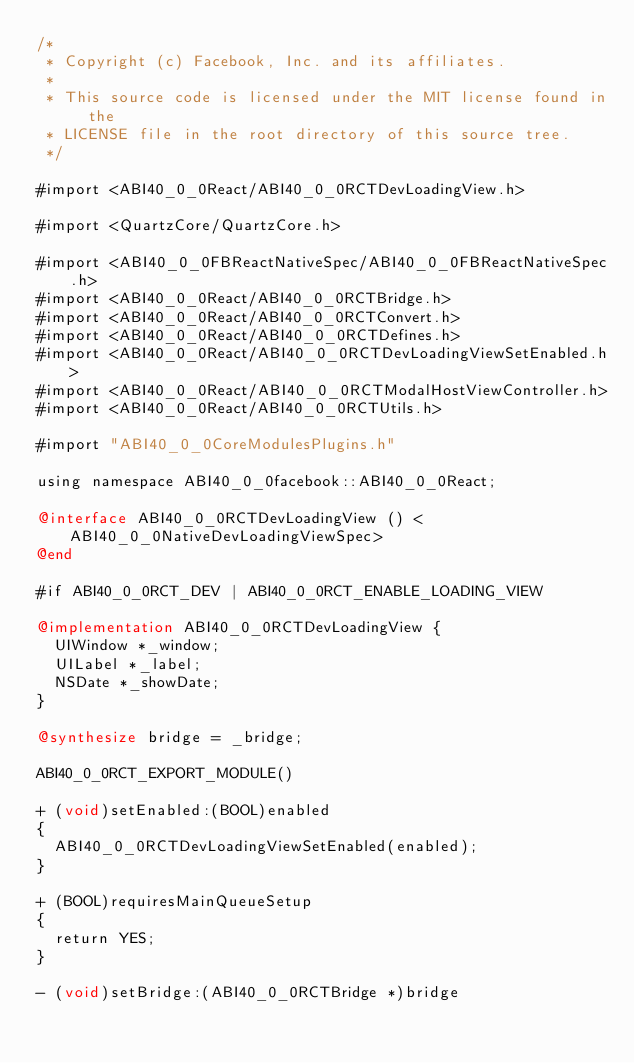Convert code to text. <code><loc_0><loc_0><loc_500><loc_500><_ObjectiveC_>/*
 * Copyright (c) Facebook, Inc. and its affiliates.
 *
 * This source code is licensed under the MIT license found in the
 * LICENSE file in the root directory of this source tree.
 */

#import <ABI40_0_0React/ABI40_0_0RCTDevLoadingView.h>

#import <QuartzCore/QuartzCore.h>

#import <ABI40_0_0FBReactNativeSpec/ABI40_0_0FBReactNativeSpec.h>
#import <ABI40_0_0React/ABI40_0_0RCTBridge.h>
#import <ABI40_0_0React/ABI40_0_0RCTConvert.h>
#import <ABI40_0_0React/ABI40_0_0RCTDefines.h>
#import <ABI40_0_0React/ABI40_0_0RCTDevLoadingViewSetEnabled.h>
#import <ABI40_0_0React/ABI40_0_0RCTModalHostViewController.h>
#import <ABI40_0_0React/ABI40_0_0RCTUtils.h>

#import "ABI40_0_0CoreModulesPlugins.h"

using namespace ABI40_0_0facebook::ABI40_0_0React;

@interface ABI40_0_0RCTDevLoadingView () <ABI40_0_0NativeDevLoadingViewSpec>
@end

#if ABI40_0_0RCT_DEV | ABI40_0_0RCT_ENABLE_LOADING_VIEW

@implementation ABI40_0_0RCTDevLoadingView {
  UIWindow *_window;
  UILabel *_label;
  NSDate *_showDate;
}

@synthesize bridge = _bridge;

ABI40_0_0RCT_EXPORT_MODULE()

+ (void)setEnabled:(BOOL)enabled
{
  ABI40_0_0RCTDevLoadingViewSetEnabled(enabled);
}

+ (BOOL)requiresMainQueueSetup
{
  return YES;
}

- (void)setBridge:(ABI40_0_0RCTBridge *)bridge</code> 